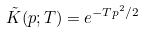Convert formula to latex. <formula><loc_0><loc_0><loc_500><loc_500>\tilde { K } ( p ; T ) = e ^ { - T p ^ { 2 } / 2 }</formula> 